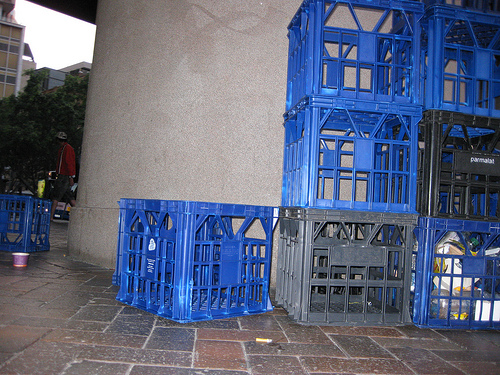<image>
Is there a crate on the floor? No. The crate is not positioned on the floor. They may be near each other, but the crate is not supported by or resting on top of the floor. Is the trays behind the floor? No. The trays is not behind the floor. From this viewpoint, the trays appears to be positioned elsewhere in the scene. 